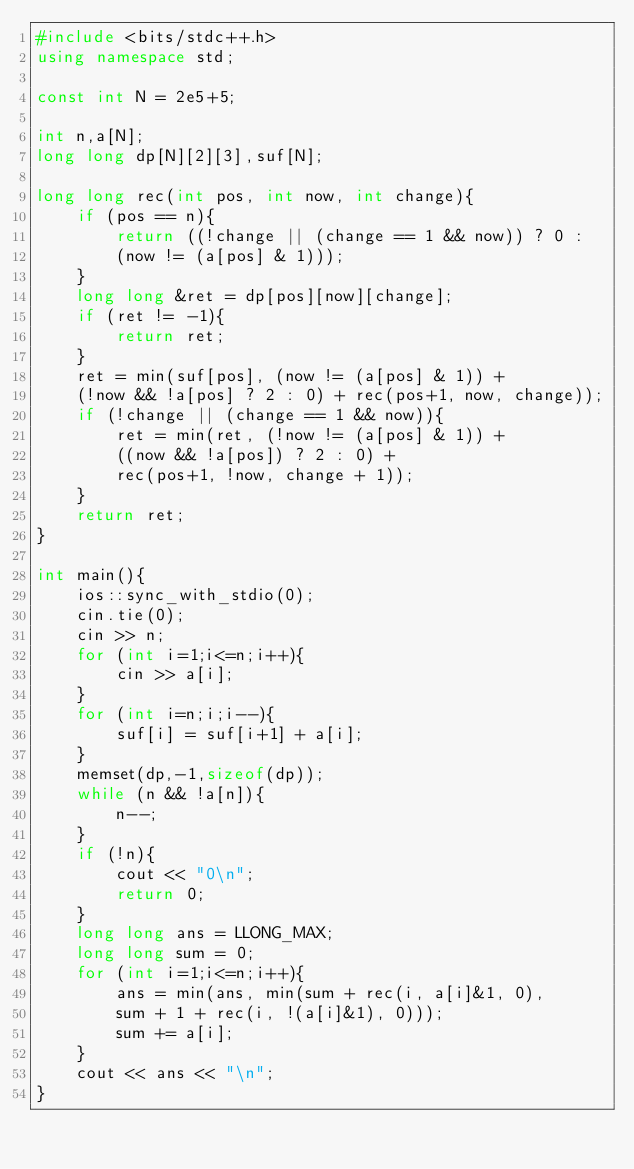Convert code to text. <code><loc_0><loc_0><loc_500><loc_500><_C++_>#include <bits/stdc++.h>
using namespace std;

const int N = 2e5+5;

int n,a[N];
long long dp[N][2][3],suf[N];

long long rec(int pos, int now, int change){
	if (pos == n){
		return ((!change || (change == 1 && now)) ? 0 :
		(now != (a[pos] & 1)));
	}
	long long &ret = dp[pos][now][change];
	if (ret != -1){
		return ret;
	}
	ret = min(suf[pos], (now != (a[pos] & 1)) +
	(!now && !a[pos] ? 2 : 0) + rec(pos+1, now, change));
	if (!change || (change == 1 && now)){
		ret = min(ret, (!now != (a[pos] & 1)) +
		((now && !a[pos]) ? 2 : 0) +
		rec(pos+1, !now, change + 1));
	}
	return ret;
}

int main(){
	ios::sync_with_stdio(0);
	cin.tie(0);
	cin >> n;
	for (int i=1;i<=n;i++){
		cin >> a[i];
	}
	for (int i=n;i;i--){
		suf[i] = suf[i+1] + a[i];
	}
	memset(dp,-1,sizeof(dp));
	while (n && !a[n]){
		n--;
	}
	if (!n){
		cout << "0\n";
		return 0;
	}
	long long ans = LLONG_MAX;
	long long sum = 0;
	for (int i=1;i<=n;i++){
		ans = min(ans, min(sum + rec(i, a[i]&1, 0),
		sum + 1 + rec(i, !(a[i]&1), 0)));
		sum += a[i];
	}
	cout << ans << "\n";
}</code> 